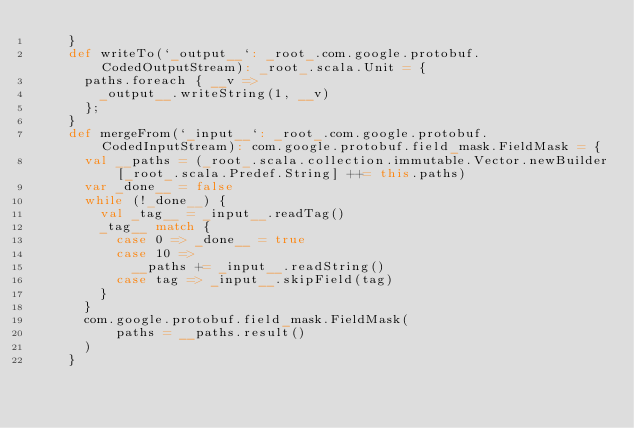<code> <loc_0><loc_0><loc_500><loc_500><_Scala_>    }
    def writeTo(`_output__`: _root_.com.google.protobuf.CodedOutputStream): _root_.scala.Unit = {
      paths.foreach { __v =>
        _output__.writeString(1, __v)
      };
    }
    def mergeFrom(`_input__`: _root_.com.google.protobuf.CodedInputStream): com.google.protobuf.field_mask.FieldMask = {
      val __paths = (_root_.scala.collection.immutable.Vector.newBuilder[_root_.scala.Predef.String] ++= this.paths)
      var _done__ = false
      while (!_done__) {
        val _tag__ = _input__.readTag()
        _tag__ match {
          case 0 => _done__ = true
          case 10 =>
            __paths += _input__.readString()
          case tag => _input__.skipField(tag)
        }
      }
      com.google.protobuf.field_mask.FieldMask(
          paths = __paths.result()
      )
    }</code> 